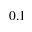Convert formula to latex. <formula><loc_0><loc_0><loc_500><loc_500>0 . 1</formula> 